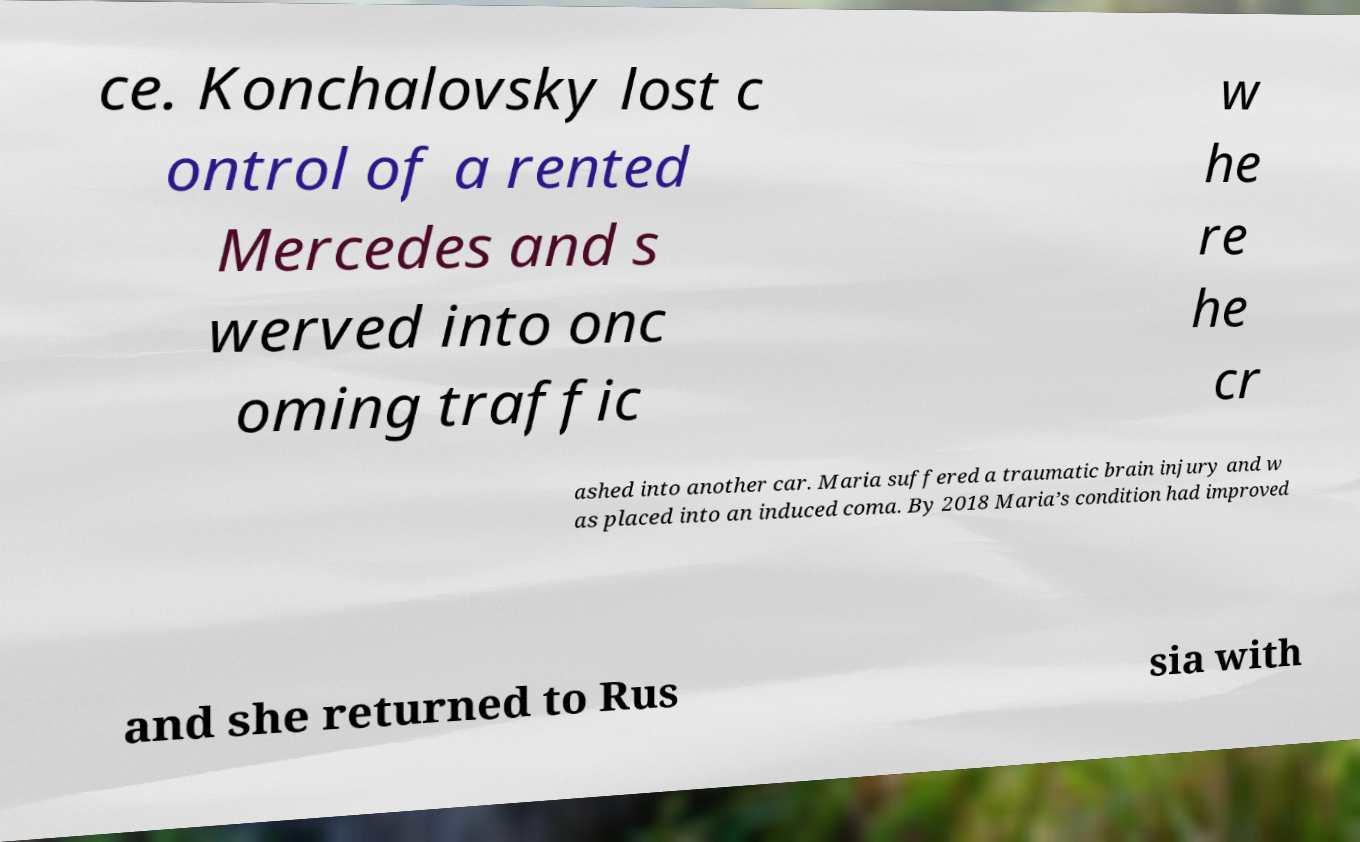I need the written content from this picture converted into text. Can you do that? ce. Konchalovsky lost c ontrol of a rented Mercedes and s werved into onc oming traffic w he re he cr ashed into another car. Maria suffered a traumatic brain injury and w as placed into an induced coma. By 2018 Maria’s condition had improved and she returned to Rus sia with 